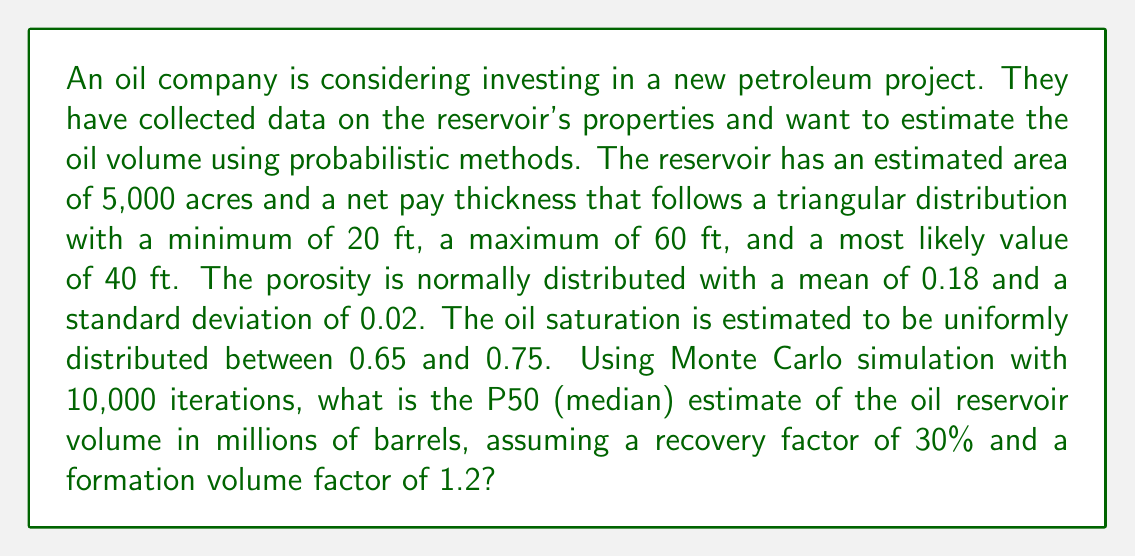Teach me how to tackle this problem. To solve this problem, we'll use Monte Carlo simulation to estimate the oil reservoir volume. We'll follow these steps:

1. Set up the probability distributions for each parameter:
   - Area (A): Constant at 5,000 acres
   - Net pay thickness (h): Triangular distribution (min=20, max=60, mode=40)
   - Porosity (φ): Normal distribution (mean=0.18, std=0.02)
   - Oil saturation (So): Uniform distribution (min=0.65, max=0.75)
   - Recovery factor (RF): Constant at 0.30
   - Formation volume factor (FVF): Constant at 1.2

2. Use the volumetric equation to calculate the oil reservoir volume:
   $$ V = \frac{7758 \times A \times h \times \phi \times S_o \times RF}{FVF} $$
   Where 7758 is the conversion factor from acre-feet to barrels.

3. Perform Monte Carlo simulation with 10,000 iterations:
   a. Generate random values for h, φ, and So based on their distributions.
   b. Calculate the volume using the volumetric equation.
   c. Repeat 10,000 times.

4. Calculate the P50 (median) estimate from the simulation results.

Python code for the simulation:

```python
import numpy as np

np.random.seed(42)
iterations = 10000

A = 5000
RF = 0.30
FVF = 1.2

h = np.random.triangular(20, 40, 60, iterations)
phi = np.random.normal(0.18, 0.02, iterations)
So = np.random.uniform(0.65, 0.75, iterations)

V = (7758 * A * h * phi * So * RF) / FVF / 1e6  # Convert to millions of barrels

P50 = np.median(V)
```

The P50 estimate from this simulation is approximately 246.5 million barrels.

Note: The actual result may vary slightly due to the random nature of Monte Carlo simulation.
Answer: 246.5 million barrels 